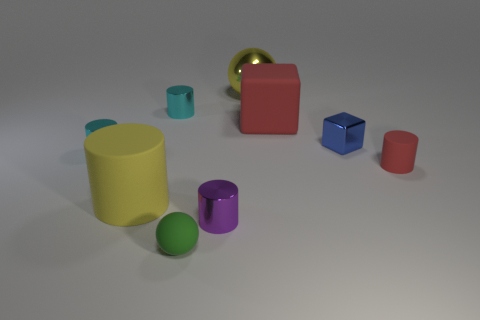There is a matte cylinder in front of the cylinder that is on the right side of the yellow thing on the right side of the large yellow cylinder; what is its color?
Offer a very short reply. Yellow. Are the blue cube and the small cylinder to the right of the small blue metallic cube made of the same material?
Provide a succinct answer. No. The red object that is the same shape as the small purple object is what size?
Ensure brevity in your answer.  Small. Are there an equal number of green balls to the left of the big rubber cylinder and cyan metallic cylinders to the right of the small block?
Your answer should be compact. Yes. How many other things are there of the same material as the small purple thing?
Offer a very short reply. 4. Are there an equal number of large red rubber blocks that are on the left side of the small green sphere and large gray metallic cylinders?
Give a very brief answer. Yes. There is a blue object; is it the same size as the red thing behind the red cylinder?
Provide a succinct answer. No. The yellow object in front of the yellow metal object has what shape?
Your answer should be compact. Cylinder. Are there any other things that are the same shape as the green matte thing?
Your response must be concise. Yes. Are there an equal number of tiny purple shiny things and brown spheres?
Your answer should be very brief. No. 